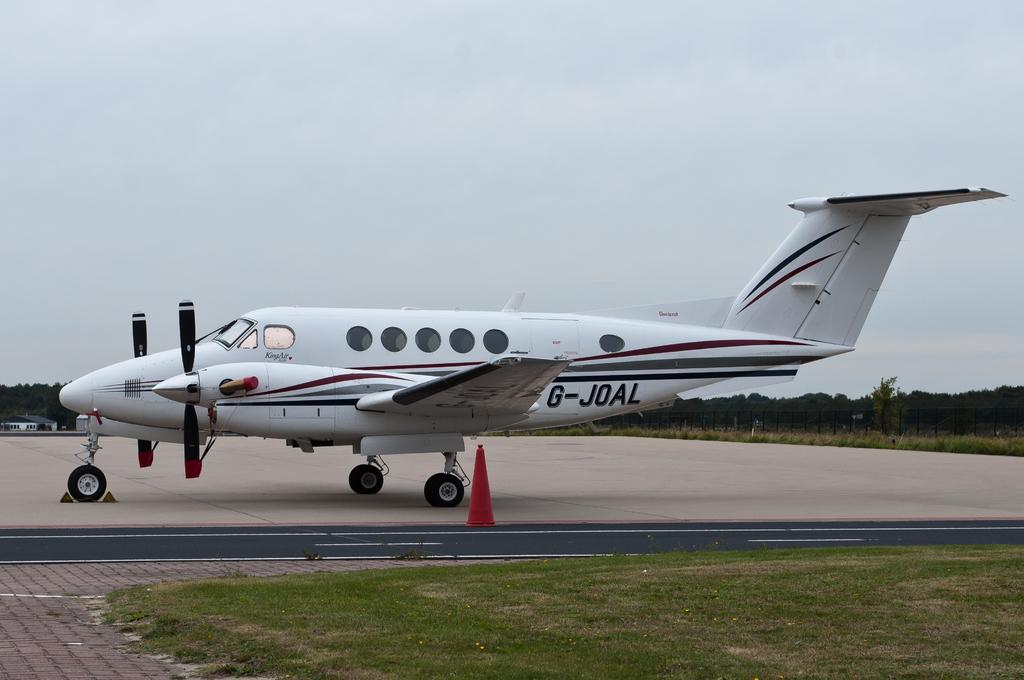Provide a one-sentence caption for the provided image. G Joal airplane that is on land and not flying. 